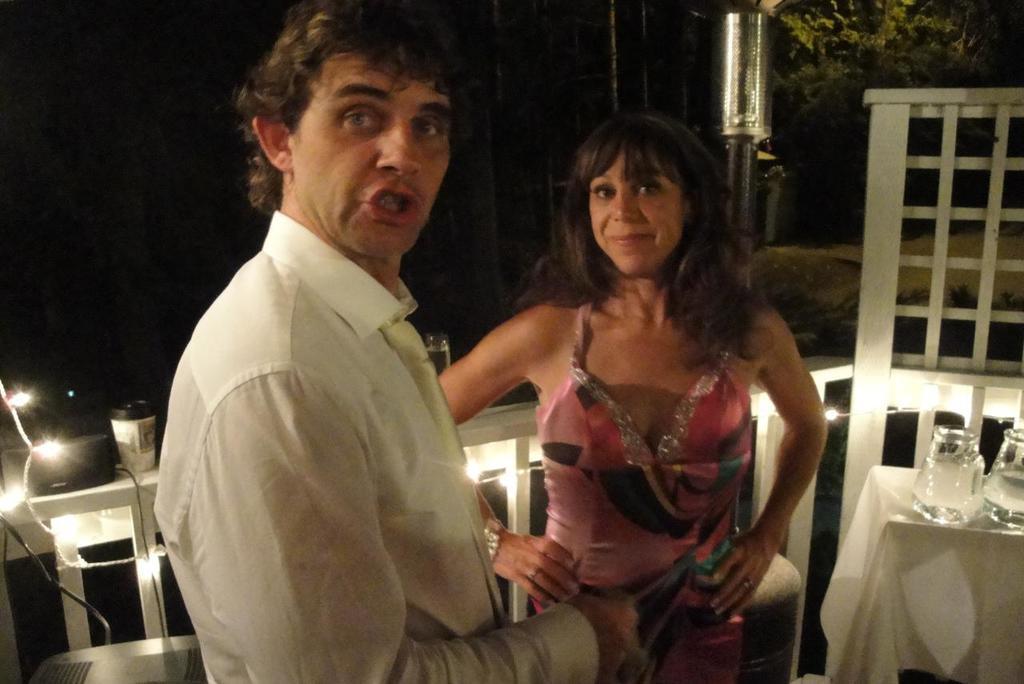In one or two sentences, can you explain what this image depicts? In the middle a man is talking, he wore white color dress. Here a woman is standing, she wore pink color dress, on the right side there are wine glasses on the table. 